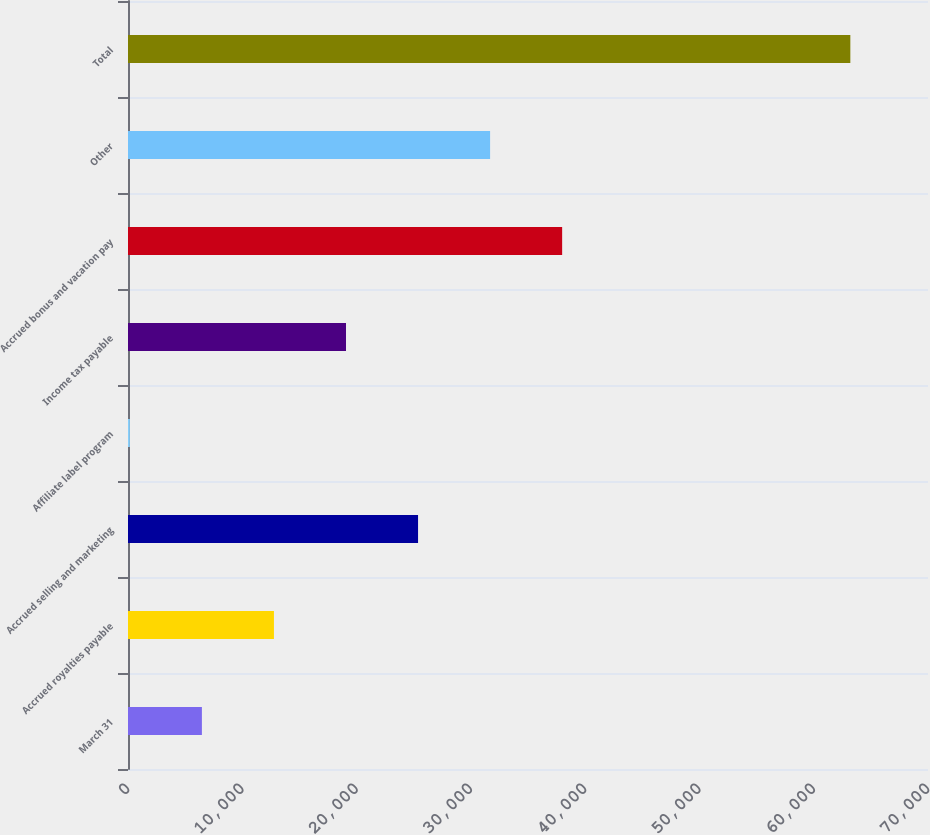Convert chart to OTSL. <chart><loc_0><loc_0><loc_500><loc_500><bar_chart><fcel>March 31<fcel>Accrued royalties payable<fcel>Accrued selling and marketing<fcel>Affiliate label program<fcel>Income tax payable<fcel>Accrued bonus and vacation pay<fcel>Other<fcel>Total<nl><fcel>6466.3<fcel>12770.6<fcel>25379.2<fcel>162<fcel>19074.9<fcel>37987.8<fcel>31683.5<fcel>63205<nl></chart> 